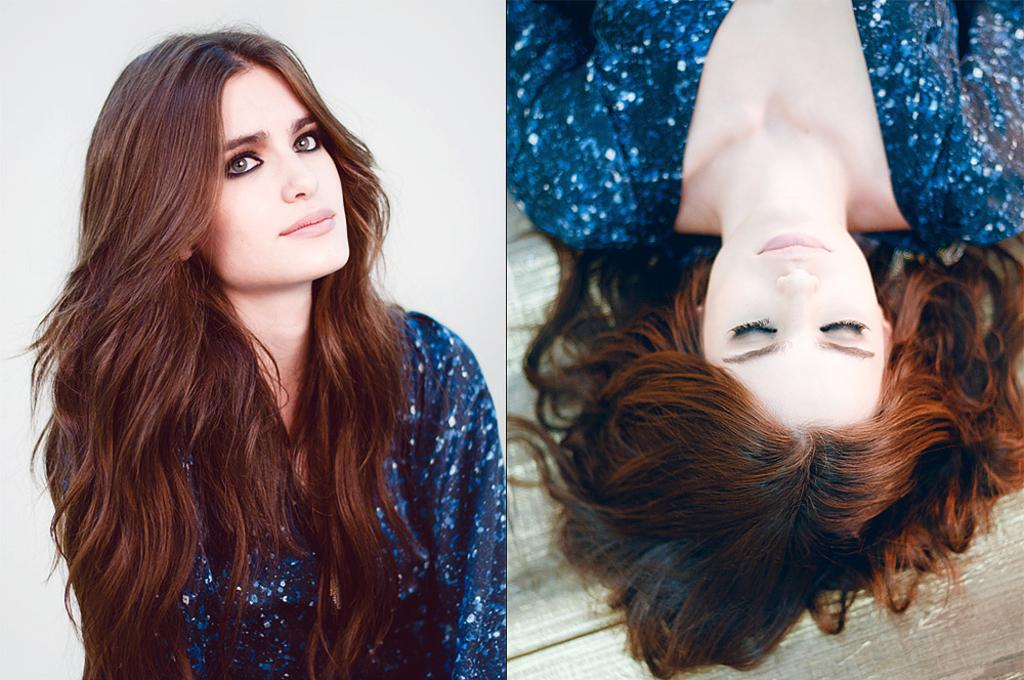What is the position of the woman on the left side of the image? There is a woman sitting on the left side of the image. What is the woman on the left side of the image wearing? The woman on the left side of the image is wearing a blue top. What is the position of the woman on the right side of the image? There is a woman lying on the right side of the image. What type of cake is being served to the woman on the right side of the image? There is no cake present in the image. How does the woman on the left side of the image apply the brake while sitting? The image does not show the woman on the left side of the image applying any brakes, as it is not a driving scenario. --- Facts: 1. There is a car in the image. 2. The car is red. 3. The car has four wheels. 4. There is a person sitting in the driver's seat. 5. The car is parked on the side of the road. Absurd Topics: parrot, sandcastle, volcano Conversation: What type of vehicle is in the image? There is a car in the image. What color is the car? The car is red. How many wheels does the car have? The car has four wheels. Who is inside the car? There is a person sitting in the driver's seat. Where is the car located in the image? The car is parked on the side of the road. Reasoning: Let's think step by step in order to produce the conversation. We start by identifying the main subject in the image, which is the car. Then, we expand the conversation to include other details about the car, such as its color, number of wheels, and the presence of a person inside. Finally, we describe the car's location in the image. Each question is designed to elicit a specific detail about the image that is known from the provided facts. Absurd Question/Answer: Can you see a parrot sitting on the roof of the car in the image? No, there is no parrot present in the image. Is the car parked near a sandcastle in the image? No, there is no sandcastle present in the image. 